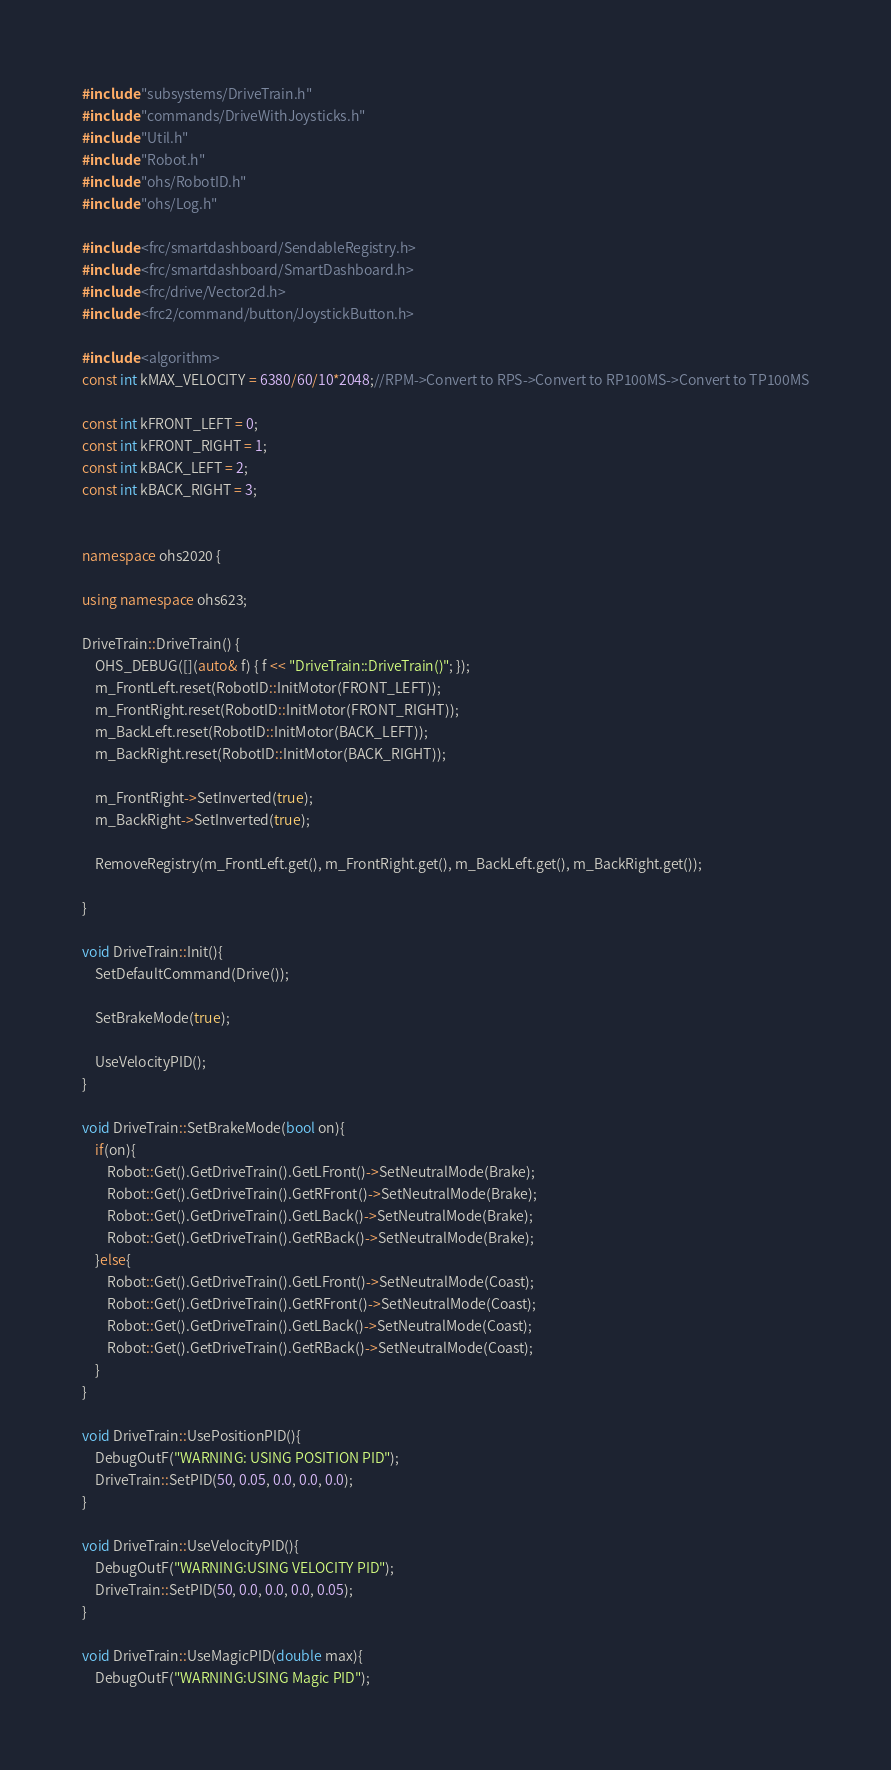Convert code to text. <code><loc_0><loc_0><loc_500><loc_500><_C++_>#include "subsystems/DriveTrain.h"
#include "commands/DriveWithJoysticks.h"
#include "Util.h"
#include "Robot.h"
#include "ohs/RobotID.h"
#include "ohs/Log.h"

#include <frc/smartdashboard/SendableRegistry.h>
#include <frc/smartdashboard/SmartDashboard.h>
#include <frc/drive/Vector2d.h>
#include <frc2/command/button/JoystickButton.h>

#include <algorithm>
const int kMAX_VELOCITY = 6380/60/10*2048;//RPM->Convert to RPS->Convert to RP100MS->Convert to TP100MS

const int kFRONT_LEFT = 0;
const int kFRONT_RIGHT = 1;
const int kBACK_LEFT = 2;
const int kBACK_RIGHT = 3;


namespace ohs2020 {

using namespace ohs623;

DriveTrain::DriveTrain() {
	OHS_DEBUG([](auto& f) { f << "DriveTrain::DriveTrain()"; });
	m_FrontLeft.reset(RobotID::InitMotor(FRONT_LEFT));
	m_FrontRight.reset(RobotID::InitMotor(FRONT_RIGHT));
	m_BackLeft.reset(RobotID::InitMotor(BACK_LEFT));
	m_BackRight.reset(RobotID::InitMotor(BACK_RIGHT));

	m_FrontRight->SetInverted(true);
	m_BackRight->SetInverted(true);

	RemoveRegistry(m_FrontLeft.get(), m_FrontRight.get(), m_BackLeft.get(), m_BackRight.get());

}
  
void DriveTrain::Init(){
	SetDefaultCommand(Drive()); 

	SetBrakeMode(true);

	UseVelocityPID();
}

void DriveTrain::SetBrakeMode(bool on){
	if(on){
		Robot::Get().GetDriveTrain().GetLFront()->SetNeutralMode(Brake);
		Robot::Get().GetDriveTrain().GetRFront()->SetNeutralMode(Brake);
		Robot::Get().GetDriveTrain().GetLBack()->SetNeutralMode(Brake);
		Robot::Get().GetDriveTrain().GetRBack()->SetNeutralMode(Brake);
	}else{
		Robot::Get().GetDriveTrain().GetLFront()->SetNeutralMode(Coast);
		Robot::Get().GetDriveTrain().GetRFront()->SetNeutralMode(Coast);
		Robot::Get().GetDriveTrain().GetLBack()->SetNeutralMode(Coast);
		Robot::Get().GetDriveTrain().GetRBack()->SetNeutralMode(Coast);
	}
}

void DriveTrain::UsePositionPID(){
	DebugOutF("WARNING: USING POSITION PID");
	DriveTrain::SetPID(50, 0.05, 0.0, 0.0, 0.0);
}

void DriveTrain::UseVelocityPID(){
	DebugOutF("WARNING:USING VELOCITY PID");
	DriveTrain::SetPID(50, 0.0, 0.0, 0.0, 0.05);
}

void DriveTrain::UseMagicPID(double max){
	DebugOutF("WARNING:USING Magic PID");</code> 